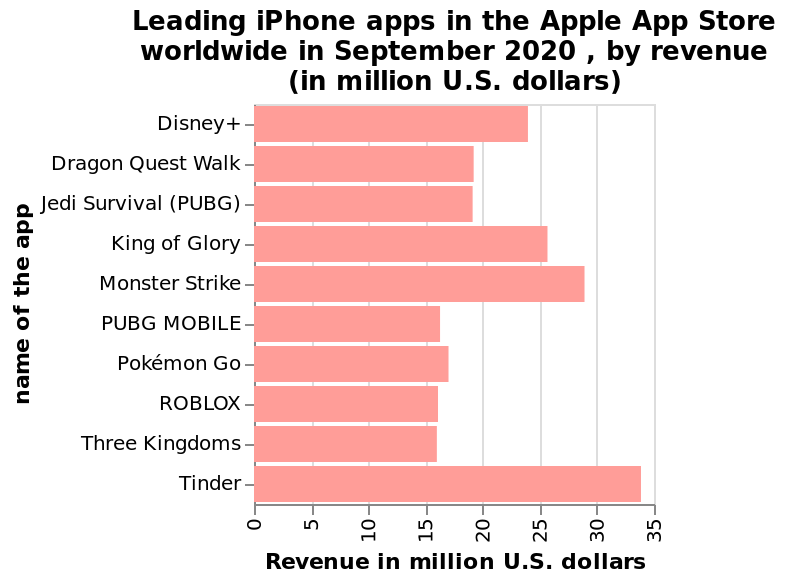<image>
What is the title of the bar diagram?  The title of the bar diagram is "Leading iPhone apps in the Apple App Store worldwide in September 2020, by revenue (in million U.S. dollars)." 